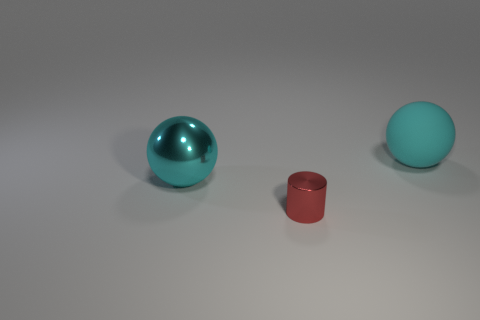Is there any other thing that has the same size as the red metallic thing?
Offer a terse response. No. The cyan object that is made of the same material as the red thing is what shape?
Give a very brief answer. Sphere. Is there anything else of the same color as the cylinder?
Offer a terse response. No. What is the material of the cyan ball behind the ball in front of the big cyan matte object?
Your answer should be compact. Rubber. Are there any large shiny things of the same shape as the large rubber object?
Provide a succinct answer. Yes. How many other things are there of the same shape as the red thing?
Provide a succinct answer. 0. The thing that is both in front of the large rubber object and behind the red cylinder has what shape?
Give a very brief answer. Sphere. What is the size of the cyan ball to the right of the large cyan metal thing?
Offer a terse response. Large. Is the cyan shiny thing the same size as the red metallic thing?
Your answer should be very brief. No. Is the number of tiny red shiny objects to the left of the shiny cylinder less than the number of large metal balls that are behind the big cyan matte object?
Offer a terse response. No. 